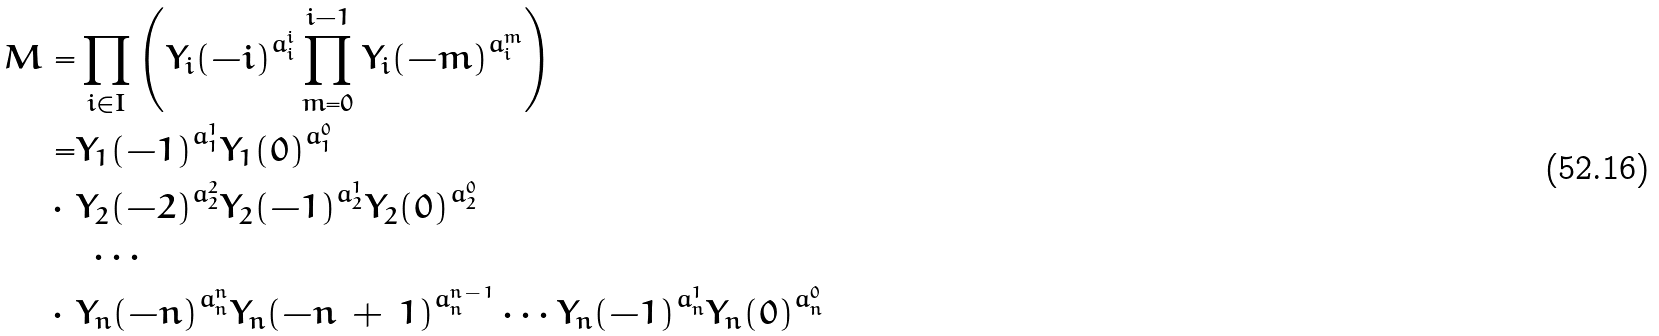<formula> <loc_0><loc_0><loc_500><loc_500>M = & \prod _ { i \in I } \left ( { Y _ { i } ( - i ) } ^ { a _ { i } ^ { i } } \prod _ { m = 0 } ^ { i - 1 } { Y _ { i } ( - m ) } ^ { a _ { i } ^ { m } } \right ) \\ = & { Y _ { 1 } ( - 1 ) } ^ { a _ { 1 } ^ { 1 } } { Y _ { 1 } ( 0 ) } ^ { a _ { 1 } ^ { 0 } } \\ \cdot \ & { Y _ { 2 } ( - 2 ) } ^ { a _ { 2 } ^ { 2 } } { Y _ { 2 } ( - 1 ) } ^ { a _ { 2 } ^ { 1 } } { Y _ { 2 } ( 0 ) } ^ { a _ { 2 } ^ { 0 } } \\ & \ \cdots \\ \cdot \ & { Y _ { n } ( - n ) } ^ { a _ { n } ^ { n } } { Y _ { n } ( - n \, + \, 1 ) } ^ { a _ { n } ^ { n \, - \, 1 } } \cdots { Y _ { n } ( - 1 ) } ^ { a _ { n } ^ { 1 } } { Y _ { n } ( 0 ) } ^ { a _ { n } ^ { 0 } }</formula> 